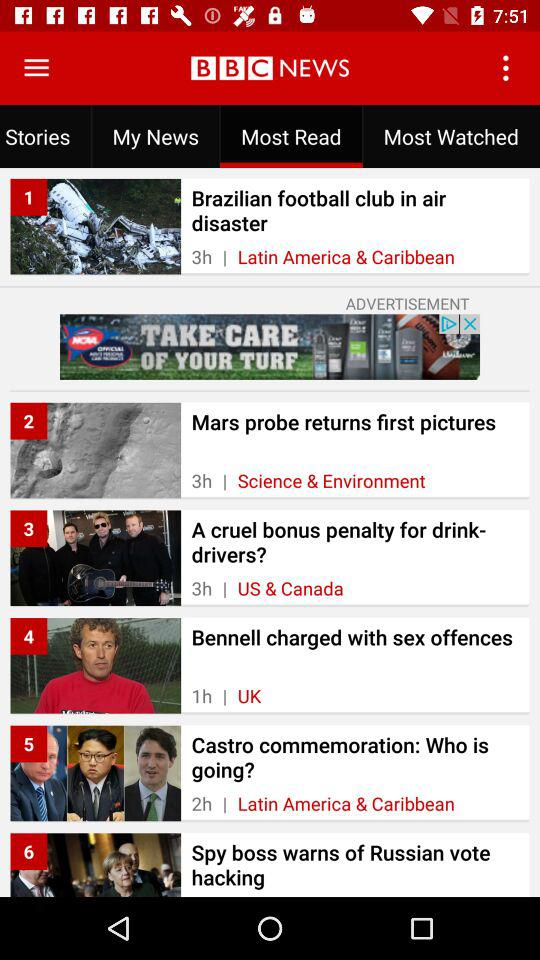How many stories are from the Latin America & Caribbean region?
Answer the question using a single word or phrase. 2 